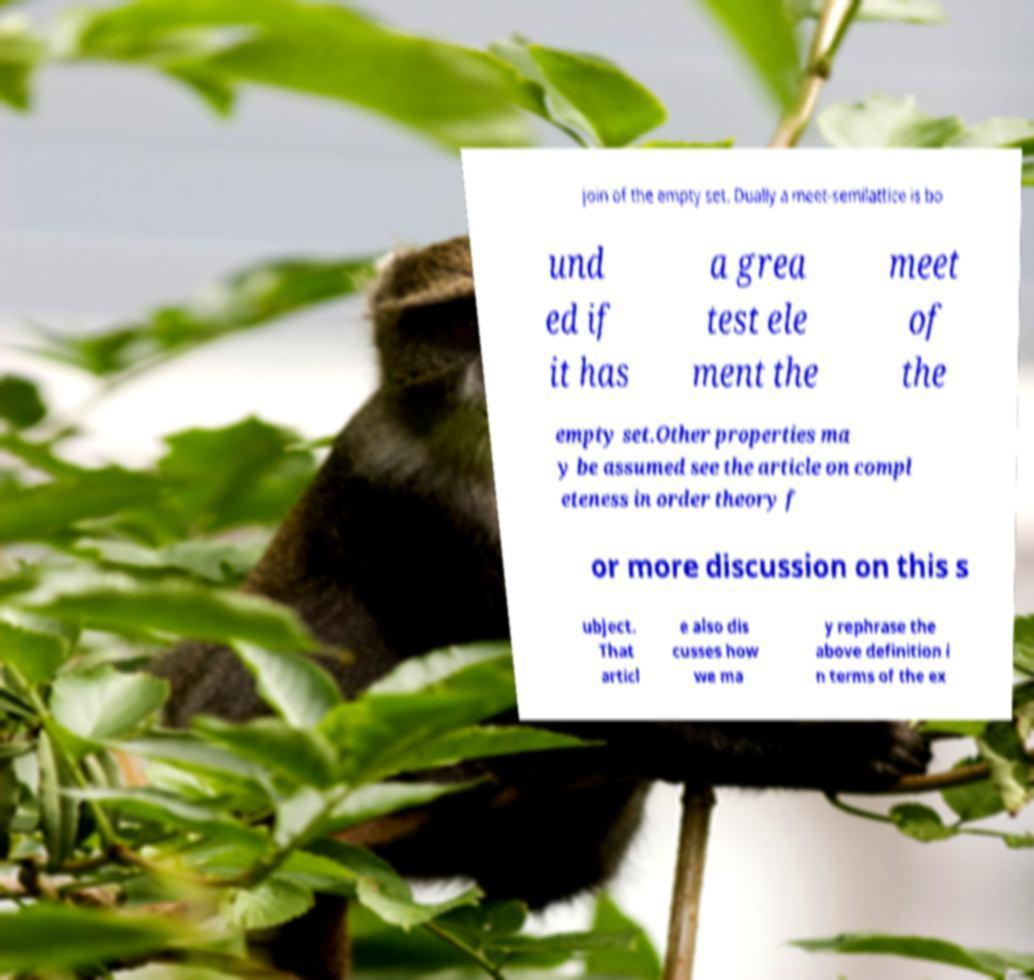What messages or text are displayed in this image? I need them in a readable, typed format. join of the empty set. Dually a meet-semilattice is bo und ed if it has a grea test ele ment the meet of the empty set.Other properties ma y be assumed see the article on compl eteness in order theory f or more discussion on this s ubject. That articl e also dis cusses how we ma y rephrase the above definition i n terms of the ex 